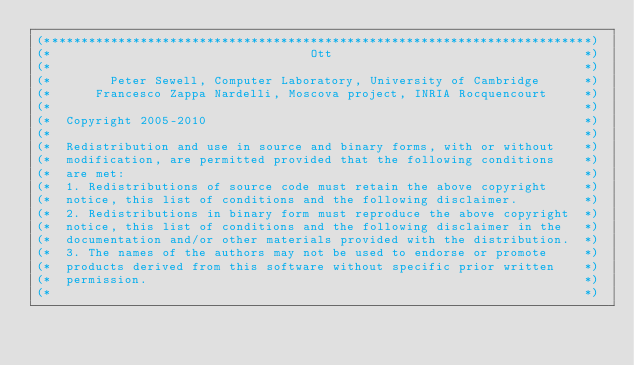<code> <loc_0><loc_0><loc_500><loc_500><_OCaml_>(**************************************************************************)
(*                                   Ott                                  *)
(*                                                                        *)
(*        Peter Sewell, Computer Laboratory, University of Cambridge      *)
(*      Francesco Zappa Nardelli, Moscova project, INRIA Rocquencourt     *)
(*                                                                        *)
(*  Copyright 2005-2010                                                   *)
(*                                                                        *)
(*  Redistribution and use in source and binary forms, with or without    *)
(*  modification, are permitted provided that the following conditions    *)
(*  are met:                                                              *)
(*  1. Redistributions of source code must retain the above copyright     *)
(*  notice, this list of conditions and the following disclaimer.         *)
(*  2. Redistributions in binary form must reproduce the above copyright  *)
(*  notice, this list of conditions and the following disclaimer in the   *)
(*  documentation and/or other materials provided with the distribution.  *)
(*  3. The names of the authors may not be used to endorse or promote     *)
(*  products derived from this software without specific prior written    *)
(*  permission.                                                           *)
(*                                                                        *)</code> 